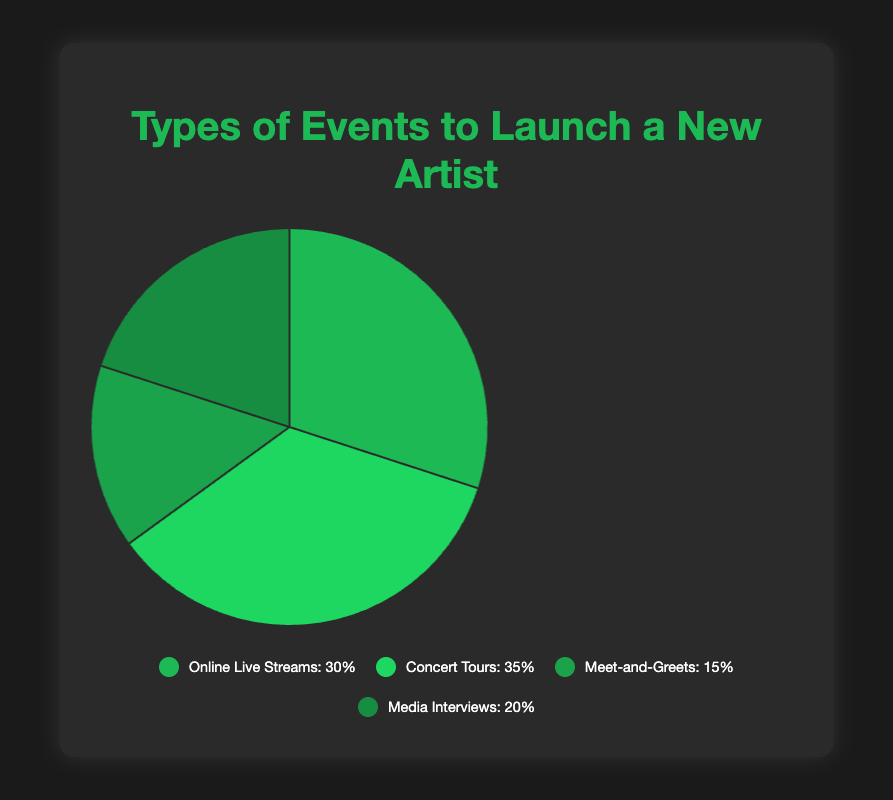What's the largest type of event used to launch a new artist? Looking at the pie chart, the largest slice corresponds to Concert Tours. Concert Tours account for 35% of the events used to launch a new artist.
Answer: Concert Tours What type of event has the smallest share in the pie chart? From the pie chart, the smallest slice refers to Meet-and-Greets. These events account for 15% of the total.
Answer: Meet-and-Greets What is the combined percentage of Online Live Streams and Media Interviews? Adding the percentages of Online Live Streams (30%) and Media Interviews (20%) gives a total of 30 + 20 = 50%.
Answer: 50% Is the percentage of Concert Tours greater than the percentage of Media Interviews? Yes, the percentage of Concert Tours (35%) is greater than the percentage of Media Interviews (20%) since 35% > 20%.
Answer: Yes How much more is the percentage of Concert Tours compared to Meet-and-Greets? The difference in percentage between Concert Tours (35%) and Meet-and-Greets (15%) is 35 - 15 = 20%.
Answer: 20% Which type of event shares the same color in the pie chart? According to the description, Concert Tours are represented in a slightly different shade of green compared to Online Live Streams, Meet-and-Greets, and Media Interviews, which all have distinct green shades. Hence, they share different shades of green.
Answer: Different green shades What are the total percentages for face-to-face events like Concert Tours and Meet-and-Greets combined? Adding the percentages of Concert Tours (35%) and Meet-and-Greets (15%), we get 35% + 15% = 50%.
Answer: 50% Which two event types combined equal the percentage of Concert Tours? The percentages of Online Live Streams (30%) and Meet-and-Greets (15%) add up to 30% + 15% = 45%, which is not equal. Adding Online Live Streams (30%) and Media Interviews (20%) gives us 50%, which is not correct either. Hence, there's no exact pair equalling 35%.
Answer: None What is the median percentage value in the pie chart? The percentages provided are 30%, 35%, 15%, and 20%. Sorting them gives: 15%, 20%, 30%, 35%. The median is the average of the two middle numbers, (20 + 30)/2 = 25%.
Answer: 25% What event type accounts for twice the percentage of Meet-and-Greets? To find twice the percentage of Meet-and-Greets (15%), we calculate 15% * 2 = 30%. Looking at the pie chart, Online Live Streams match this percentage (30%).
Answer: Online Live Streams 